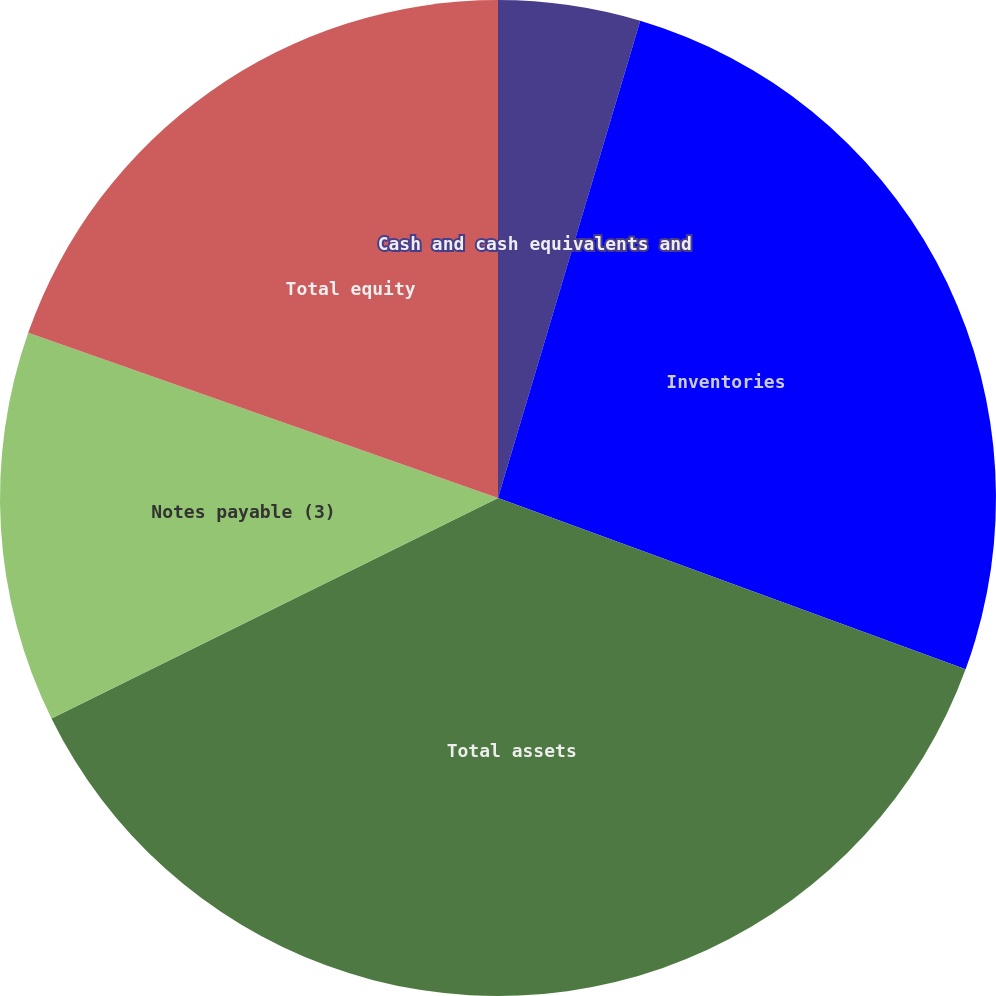Convert chart to OTSL. <chart><loc_0><loc_0><loc_500><loc_500><pie_chart><fcel>Cash and cash equivalents and<fcel>Inventories<fcel>Total assets<fcel>Notes payable (3)<fcel>Total equity<nl><fcel>4.61%<fcel>25.98%<fcel>37.11%<fcel>12.68%<fcel>19.62%<nl></chart> 